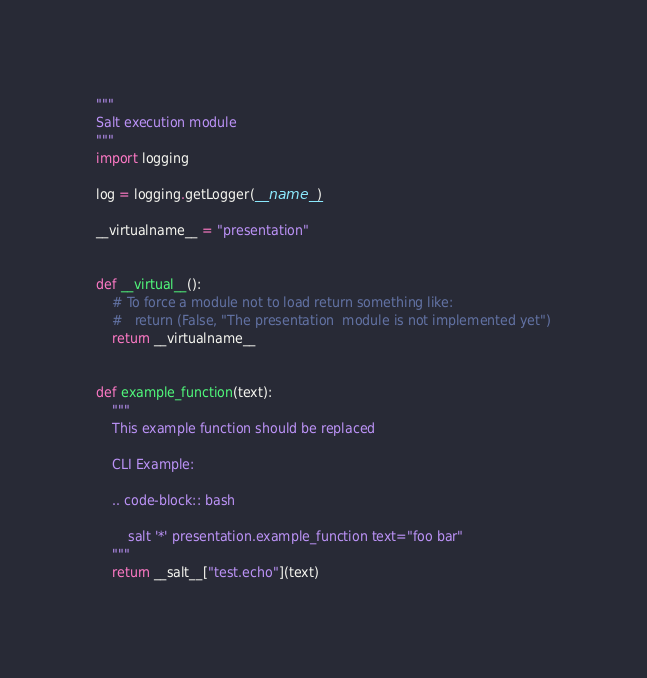<code> <loc_0><loc_0><loc_500><loc_500><_Python_>"""
Salt execution module
"""
import logging

log = logging.getLogger(__name__)

__virtualname__ = "presentation"


def __virtual__():
    # To force a module not to load return something like:
    #   return (False, "The presentation  module is not implemented yet")
    return __virtualname__


def example_function(text):
    """
    This example function should be replaced

    CLI Example:

    .. code-block:: bash

        salt '*' presentation.example_function text="foo bar"
    """
    return __salt__["test.echo"](text)
</code> 